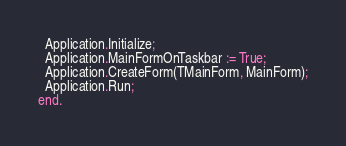<code> <loc_0><loc_0><loc_500><loc_500><_Pascal_>  Application.Initialize;
  Application.MainFormOnTaskbar := True;
  Application.CreateForm(TMainForm, MainForm);
  Application.Run;
end.
</code> 